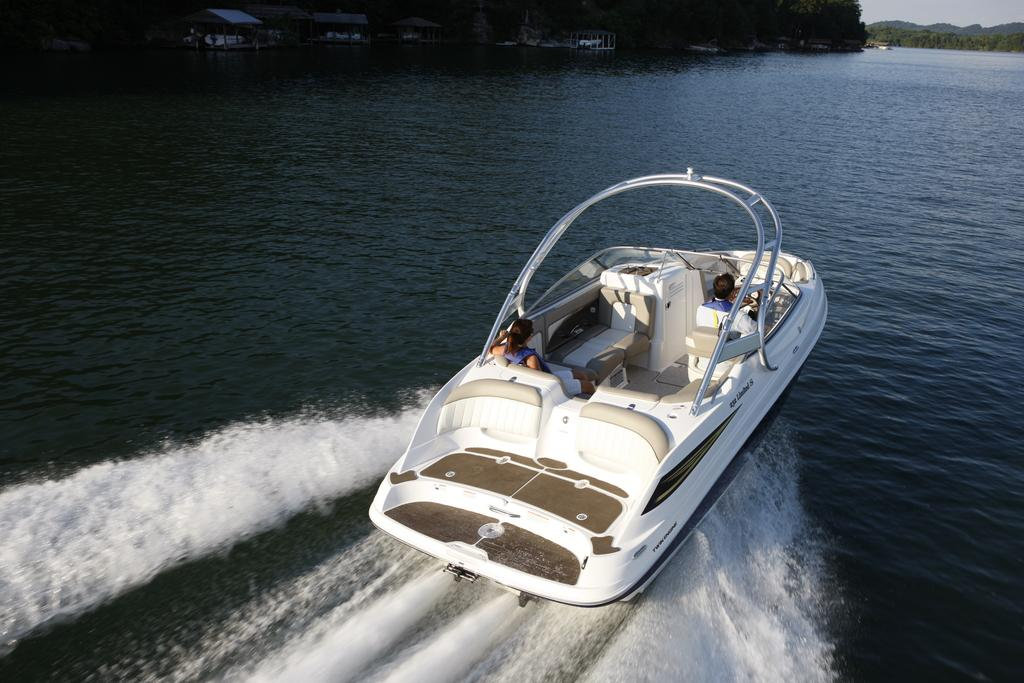What is the main subject of the image? The main subject of the image is a boat. Where is the boat located? The boat is on the water. How many people are in the boat? There are two persons sitting in the boat. What can be seen in the background of the image? There are houses and trees visible in the background of the image. What type of egg is being used to reduce friction in the image? There is no egg present in the image, and therefore no such activity can be observed. 